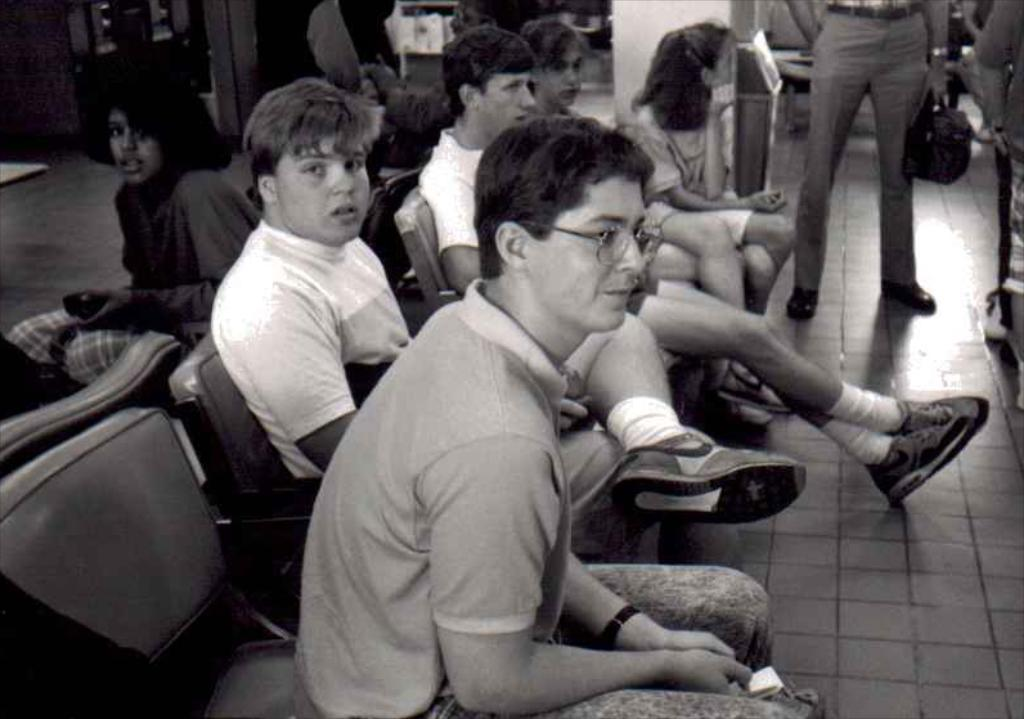What is the color scheme of the image? The image is black and white. What are the people in the image doing? Some people are sitting on chairs, while others are walking in the image. How many teeth can be seen on the donkey in the image? There is no donkey present in the image, so it is not possible to determine the number of teeth. 